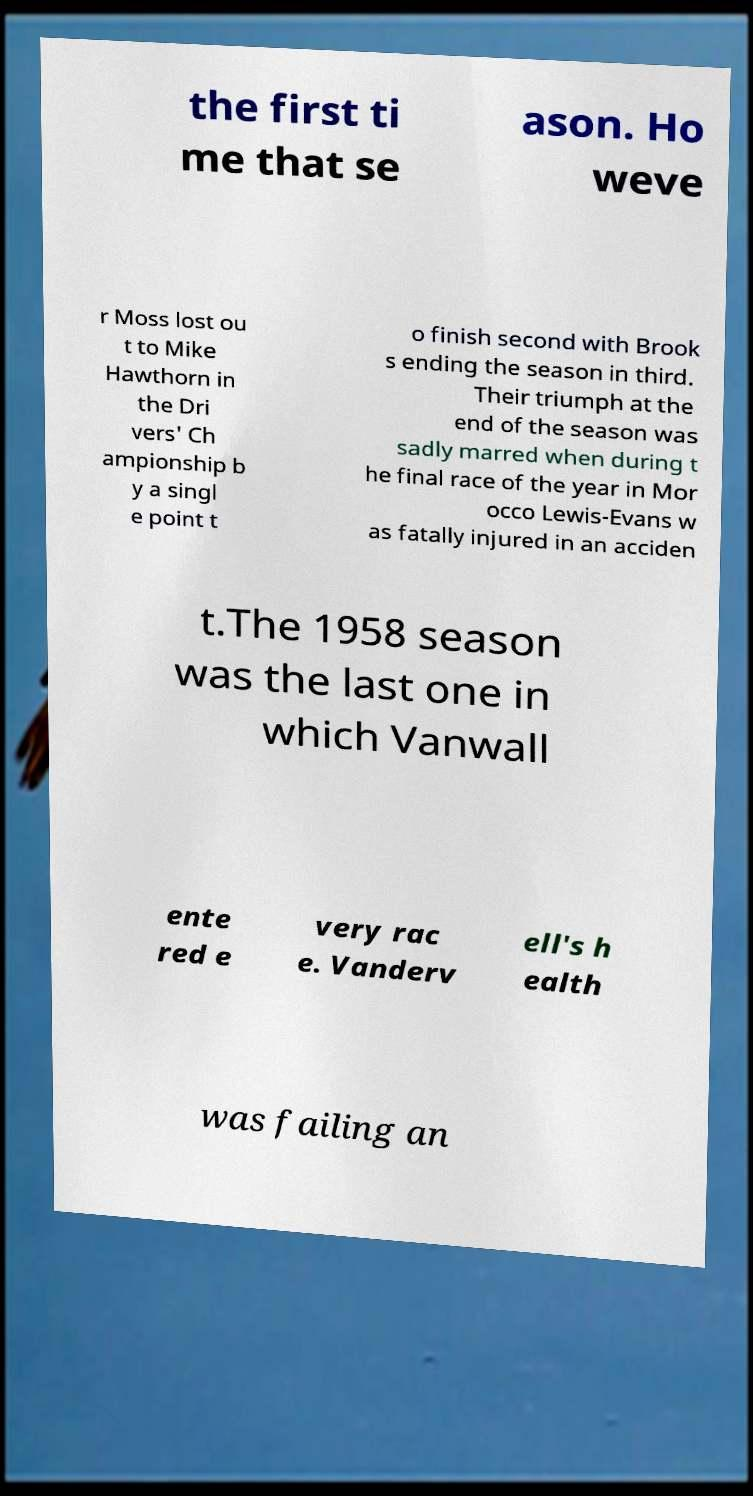Could you assist in decoding the text presented in this image and type it out clearly? the first ti me that se ason. Ho weve r Moss lost ou t to Mike Hawthorn in the Dri vers' Ch ampionship b y a singl e point t o finish second with Brook s ending the season in third. Their triumph at the end of the season was sadly marred when during t he final race of the year in Mor occo Lewis-Evans w as fatally injured in an acciden t.The 1958 season was the last one in which Vanwall ente red e very rac e. Vanderv ell's h ealth was failing an 